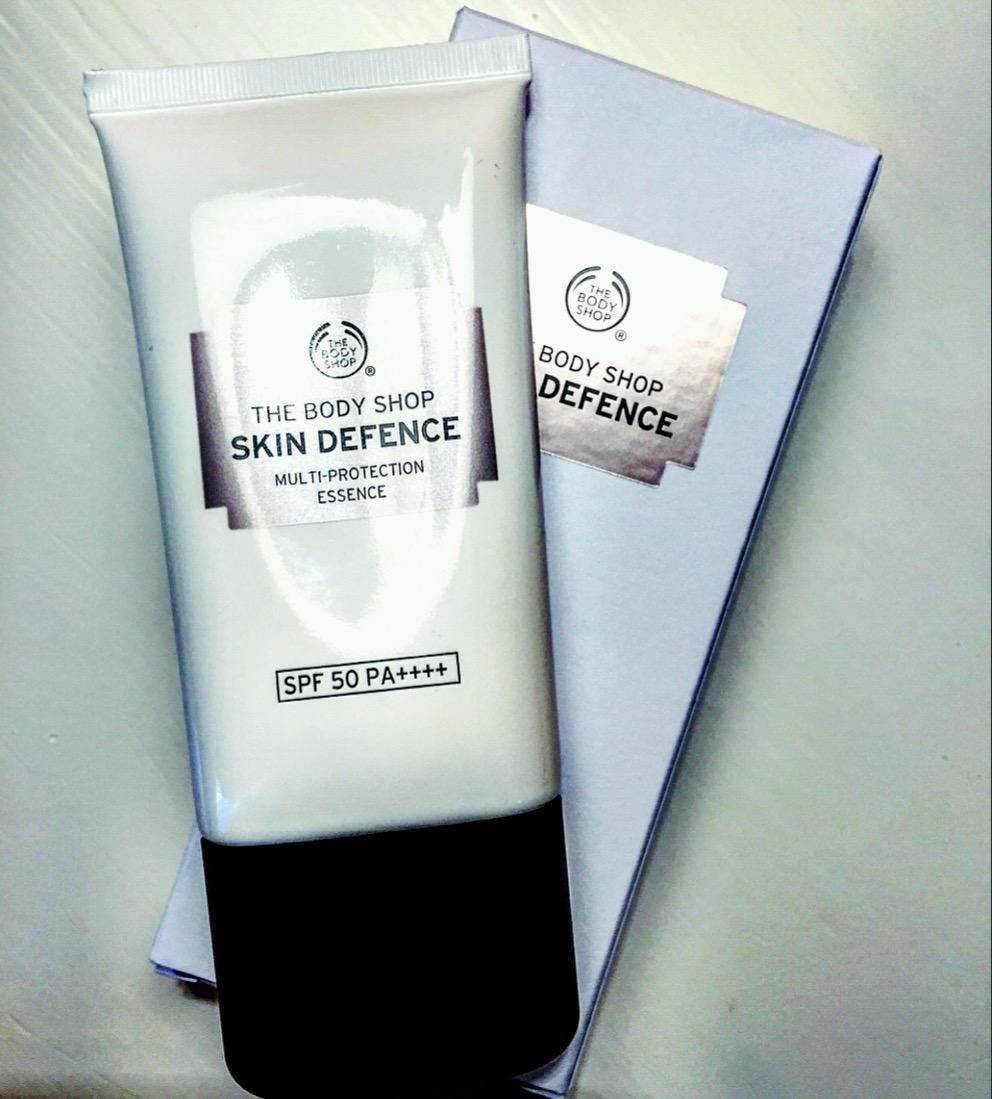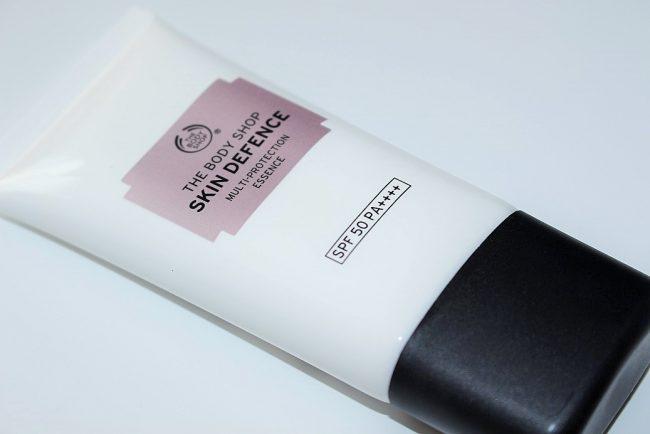The first image is the image on the left, the second image is the image on the right. Considering the images on both sides, is "There are four transparent round items filled with rosy-orange petal like colors." valid? Answer yes or no. No. The first image is the image on the left, the second image is the image on the right. For the images shown, is this caption "Both tubes shown are standing upright." true? Answer yes or no. No. 